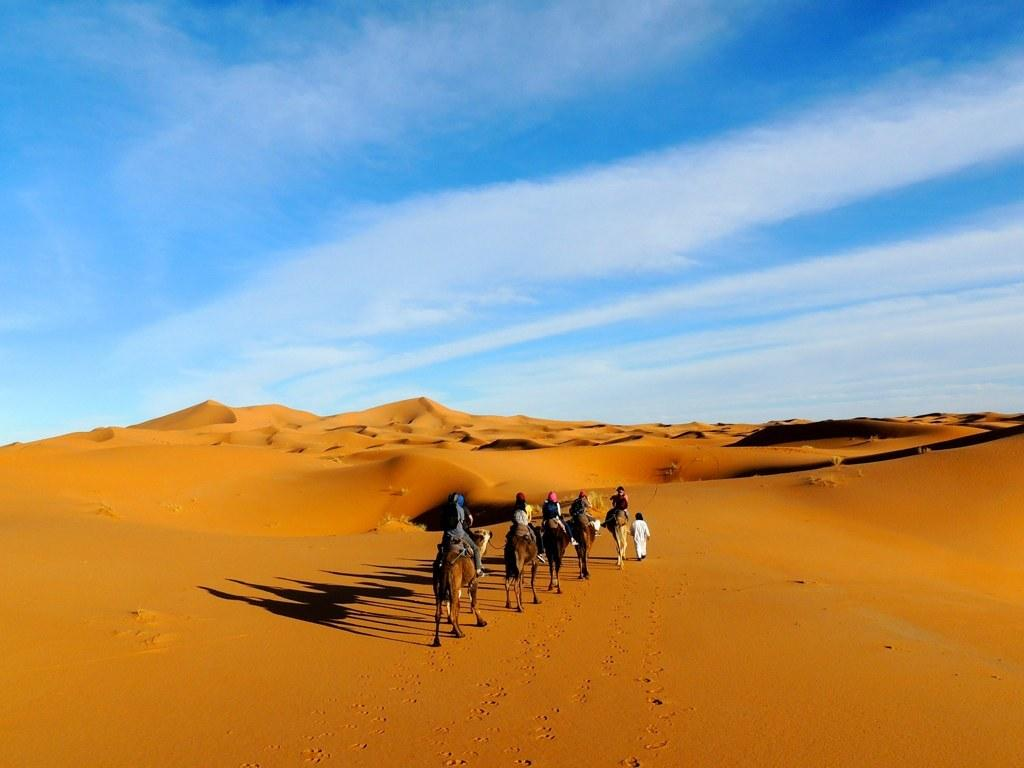What type of landscape is shown in the image? The image depicts a desert. What are the people in the image doing? There are five people riding camels and one person walking in the desert. What can be seen in the background of the image? The sky is visible in the background of the image. Where is the map located in the image? There is no map present in the image. What type of stocking is the person wearing in the image? There is no person wearing stockings in the image. 